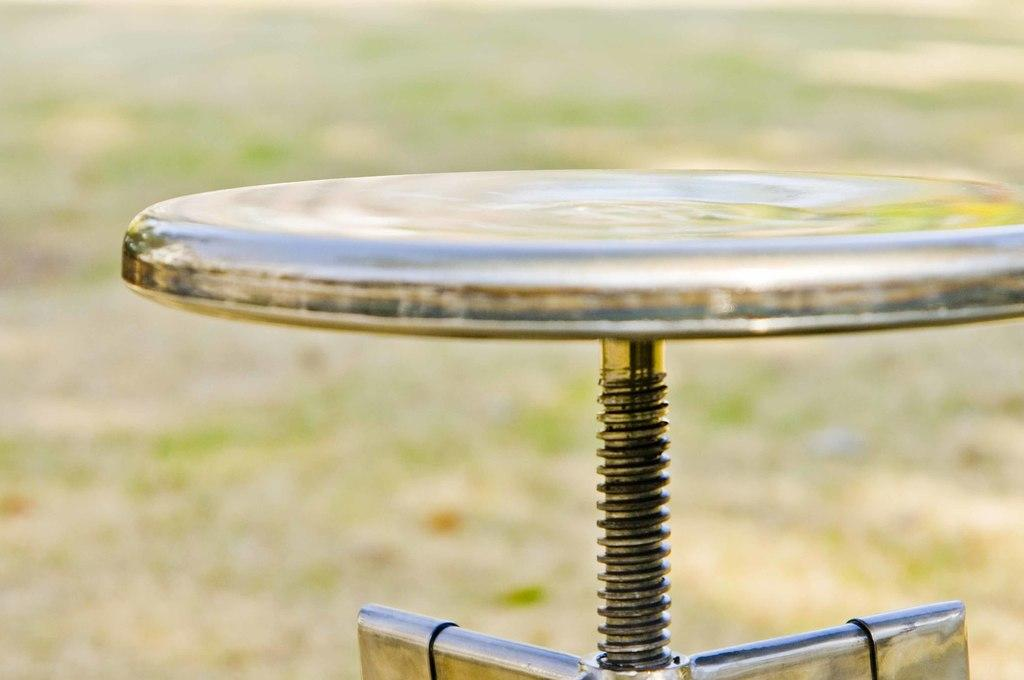What object is located in the foreground of the image? There is a stool in the foreground of the image. How would you describe the quality of the image in the background? The image is blurry in the background. Can you identify any surface or terrain at the bottom of the image? There might be ground or grass at the bottom of the image. How many birds are balancing on the beam in the image? There is no beam or birds present in the image. 